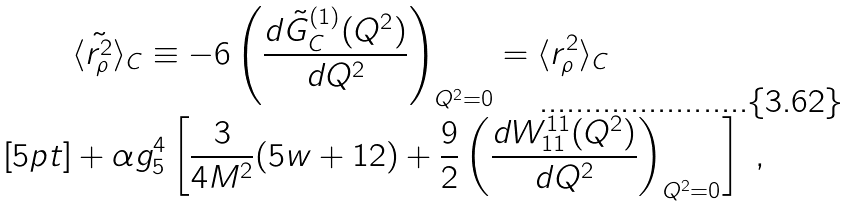<formula> <loc_0><loc_0><loc_500><loc_500>& \langle \tilde { r ^ { 2 } _ { \rho } } \rangle _ { C } \equiv - 6 \left ( \frac { d \tilde { G } ^ { ( 1 ) } _ { C } ( Q ^ { 2 } ) } { d Q ^ { 2 } } \right ) _ { Q ^ { 2 } = 0 } = \langle r ^ { 2 } _ { \rho } \rangle _ { C } \\ [ 5 p t ] & + \alpha g ^ { 4 } _ { 5 } \left [ \frac { 3 } { 4 M ^ { 2 } } ( 5 w + 1 2 ) + \frac { 9 } { 2 } \left ( \frac { d W ^ { 1 1 } _ { 1 1 } ( Q ^ { 2 } ) } { d Q ^ { 2 } } \right ) _ { Q ^ { 2 } = 0 } \right ] \ ,</formula> 